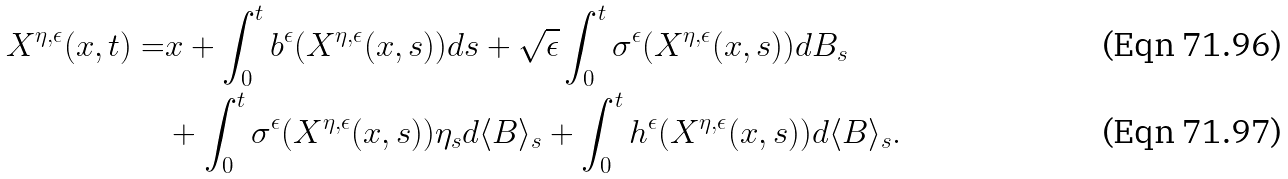Convert formula to latex. <formula><loc_0><loc_0><loc_500><loc_500>X ^ { \eta , \epsilon } ( x , t ) = & x + \int _ { 0 } ^ { t } b ^ { \epsilon } ( X ^ { \eta , \epsilon } ( x , s ) ) d s + \sqrt { \epsilon } \int _ { 0 } ^ { t } \sigma ^ { \epsilon } ( X ^ { \eta , \epsilon } ( x , s ) ) d B _ { s } \\ & + \int _ { 0 } ^ { t } \sigma ^ { \epsilon } ( X ^ { \eta , \epsilon } ( x , s ) ) \eta _ { s } d \langle B \rangle _ { s } + \int _ { 0 } ^ { t } h ^ { \epsilon } ( X ^ { \eta , \epsilon } ( x , s ) ) d \langle B \rangle _ { s } .</formula> 